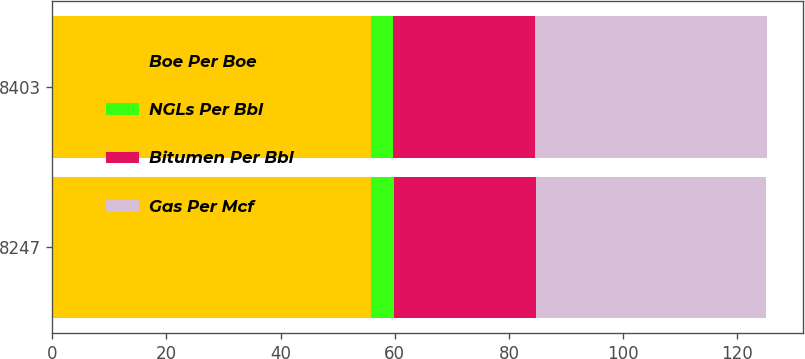Convert chart. <chart><loc_0><loc_0><loc_500><loc_500><stacked_bar_chart><ecel><fcel>8247<fcel>8403<nl><fcel>Boe Per Boe<fcel>55.88<fcel>55.88<nl><fcel>NGLs Per Bbl<fcel>3.9<fcel>3.85<nl><fcel>Bitumen Per Bbl<fcel>24.89<fcel>24.91<nl><fcel>Gas Per Mcf<fcel>40.33<fcel>40.55<nl></chart> 